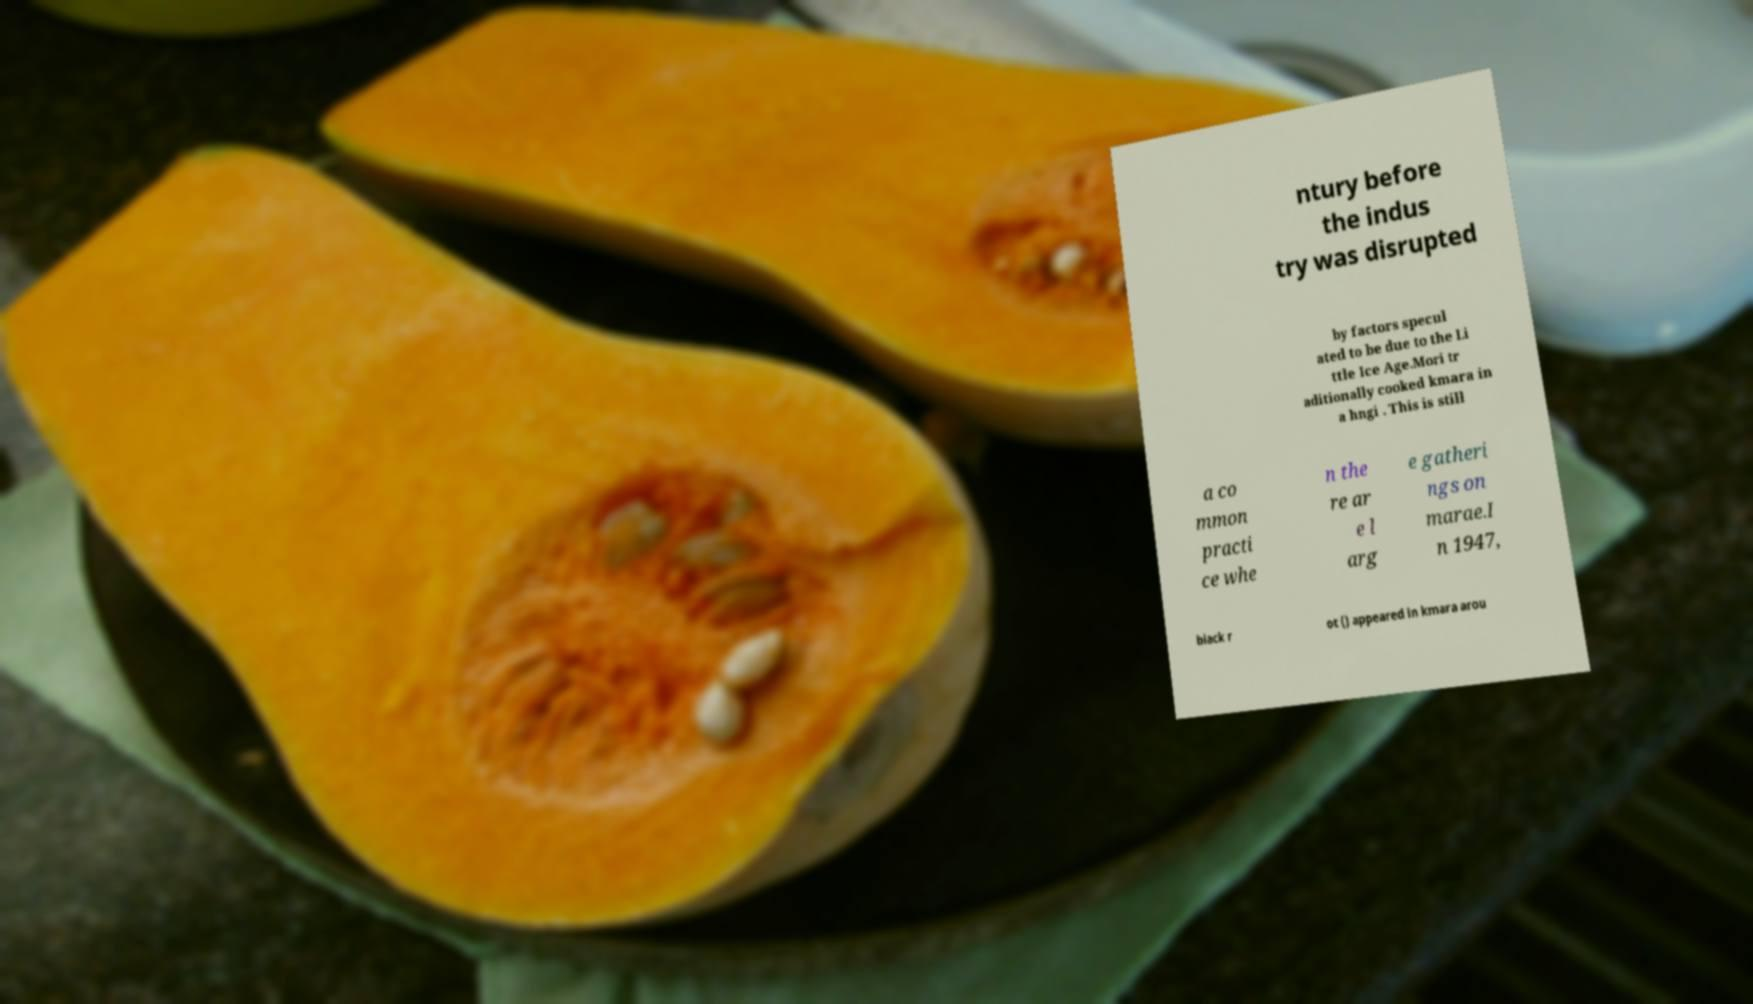I need the written content from this picture converted into text. Can you do that? ntury before the indus try was disrupted by factors specul ated to be due to the Li ttle Ice Age.Mori tr aditionally cooked kmara in a hngi . This is still a co mmon practi ce whe n the re ar e l arg e gatheri ngs on marae.I n 1947, black r ot () appeared in kmara arou 